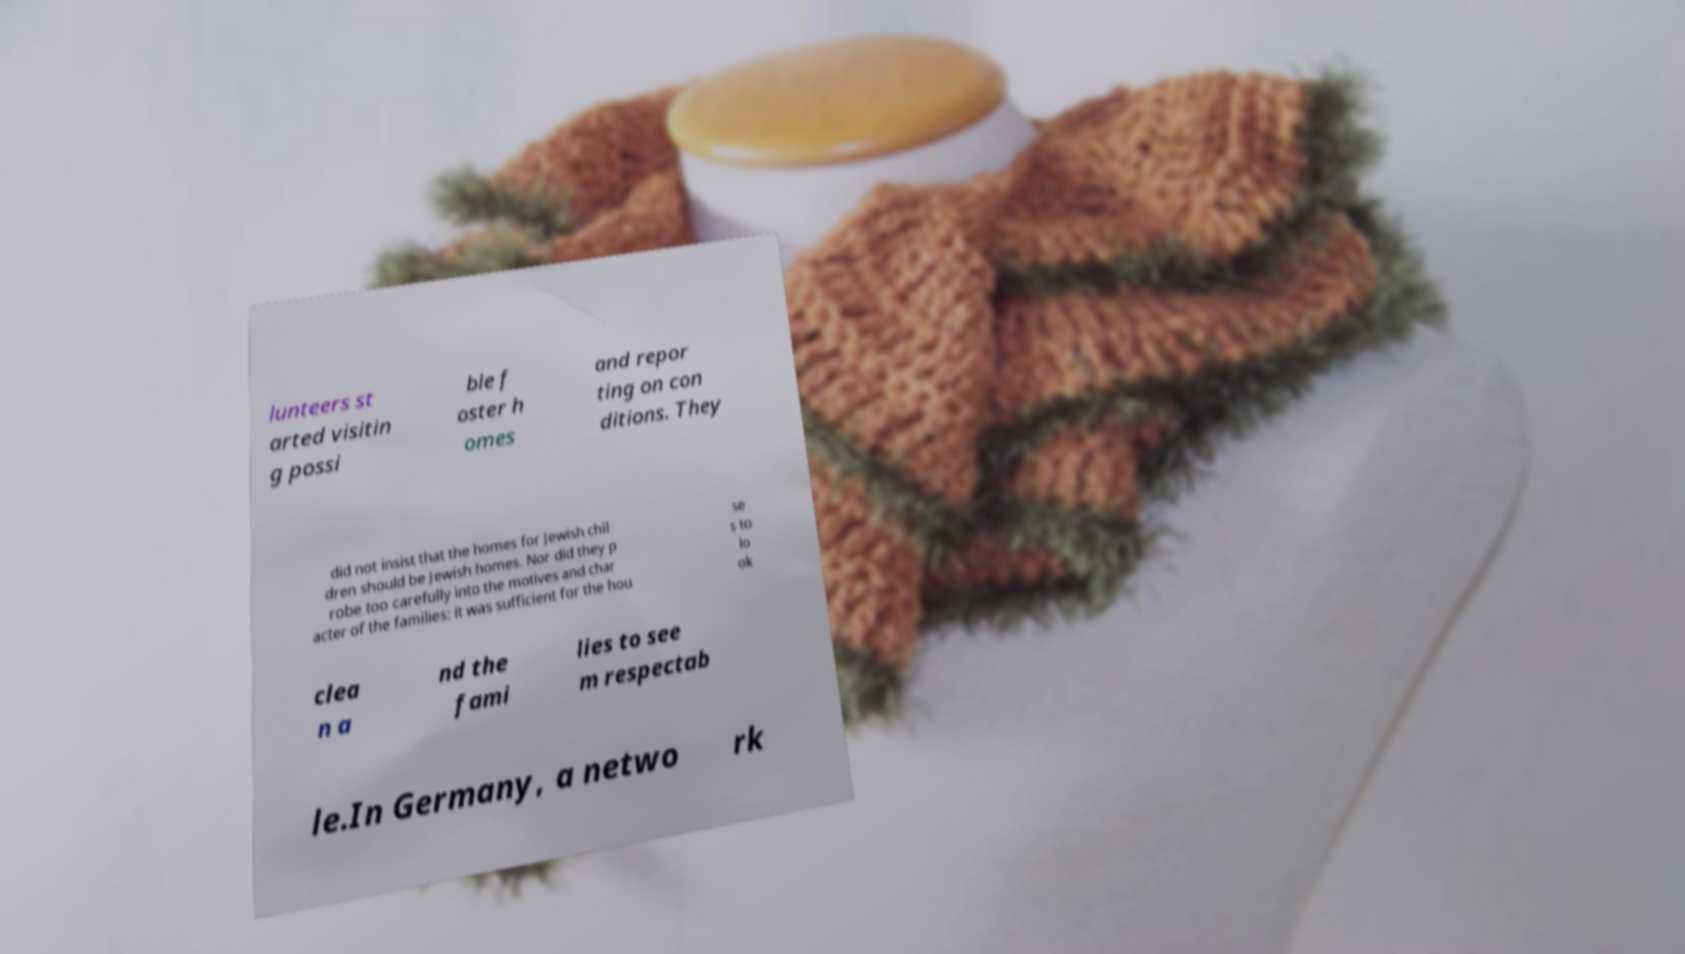There's text embedded in this image that I need extracted. Can you transcribe it verbatim? lunteers st arted visitin g possi ble f oster h omes and repor ting on con ditions. They did not insist that the homes for Jewish chil dren should be Jewish homes. Nor did they p robe too carefully into the motives and char acter of the families: it was sufficient for the hou se s to lo ok clea n a nd the fami lies to see m respectab le.In Germany, a netwo rk 